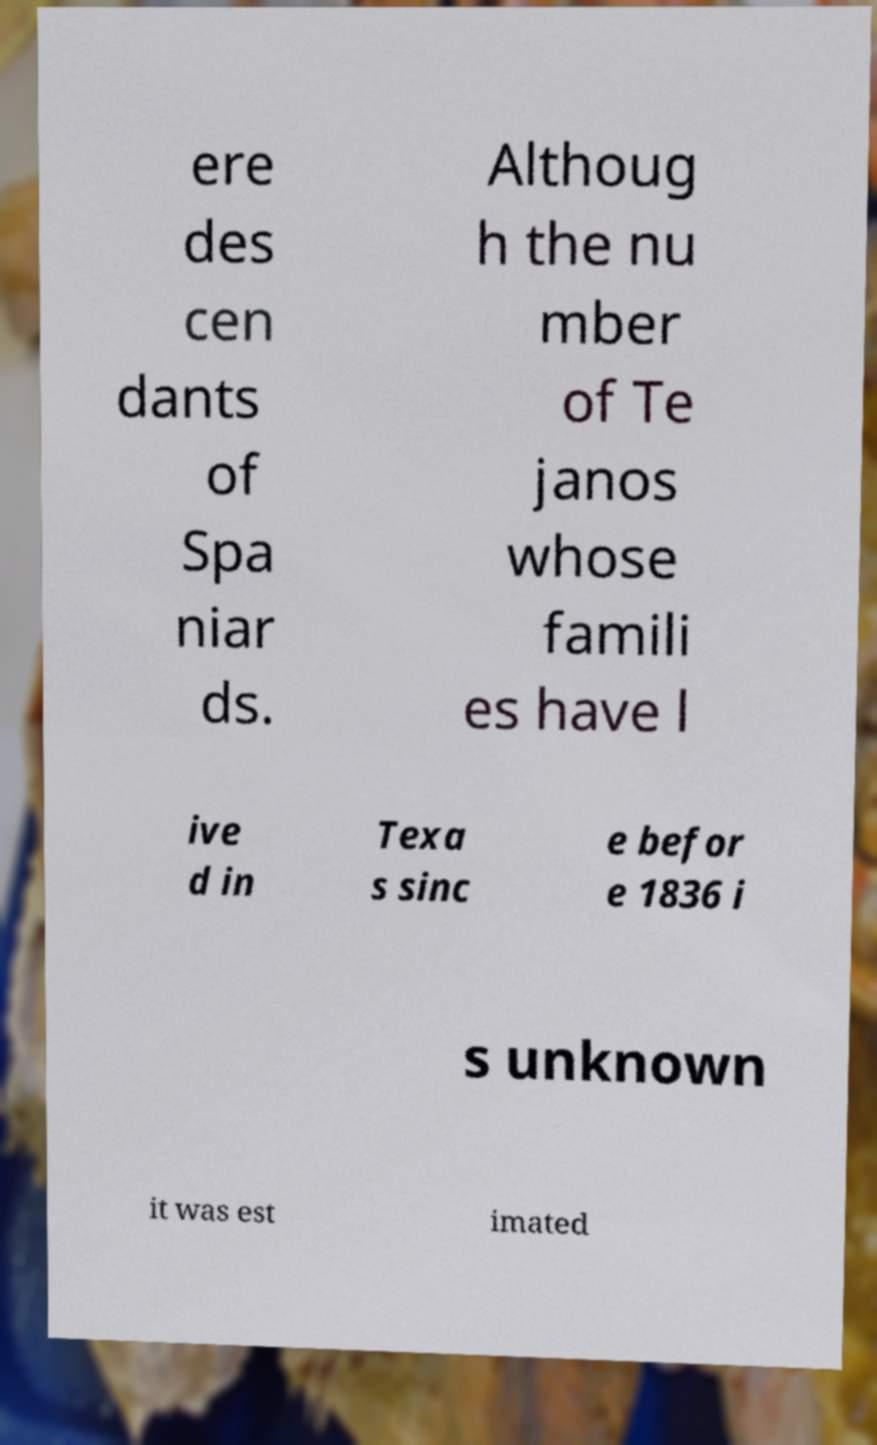There's text embedded in this image that I need extracted. Can you transcribe it verbatim? ere des cen dants of Spa niar ds. Althoug h the nu mber of Te janos whose famili es have l ive d in Texa s sinc e befor e 1836 i s unknown it was est imated 